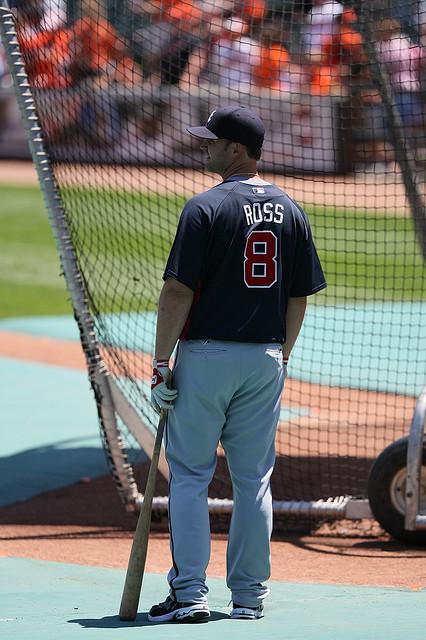What is the man standing next to?
Write a very short answer. Net. What number is on his shirt?
Give a very brief answer. 8. Is the batter fat?
Write a very short answer. No. What is number 8 holding?
Concise answer only. Baseball bat. 